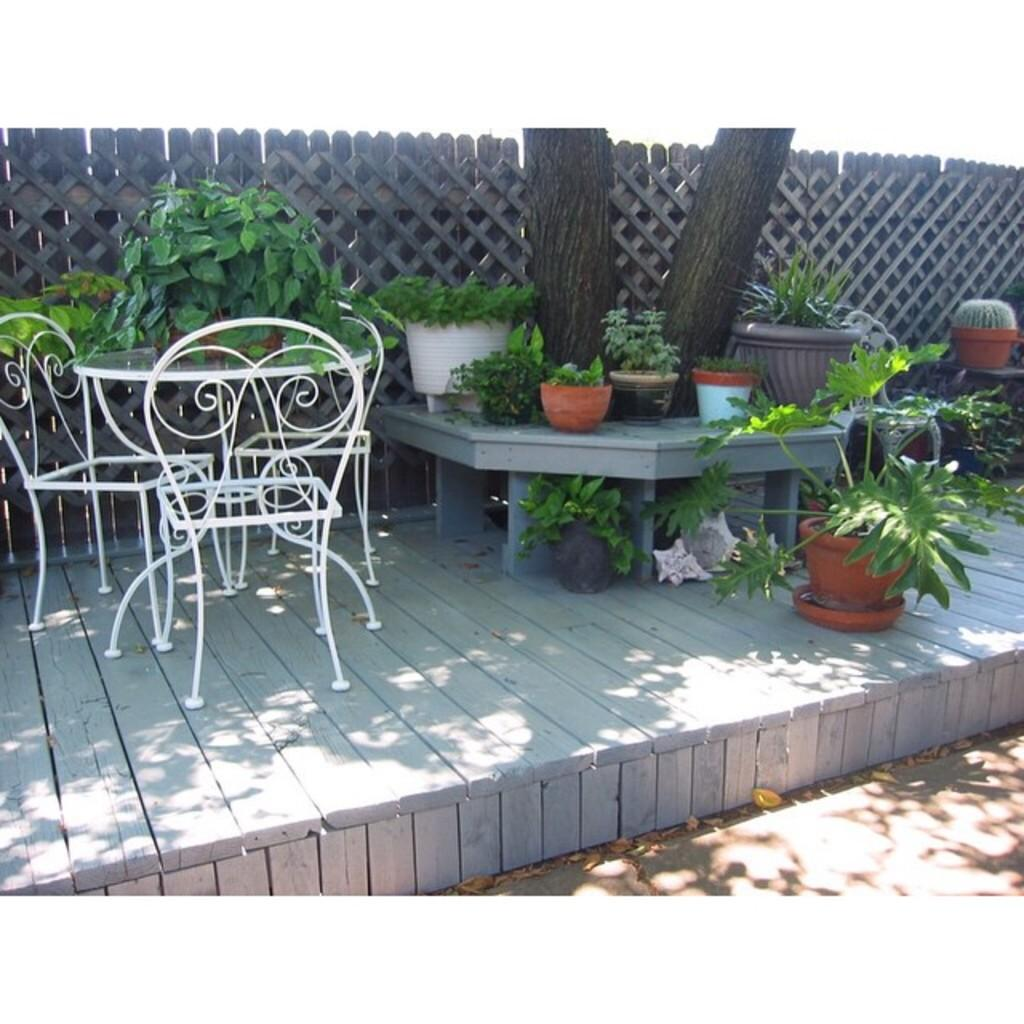What piece of furniture is present in the image? There is a table in the image. What can be found beside the table? Chairs are arranged beside the table. What type of plants are in the image? There are potted plants in the image. What large natural element is visible in the image? There is a big tree visible in the image. What type of structure is present in the image? There is a wall in the image. How are the elements arranged in the image? The elements are arranged in a place, indicating that they are organized and not randomly scattered. What type of yam is growing on the wall in the image? There is no yam growing on the wall in the image. Yams are not plants that grow on walls, and there is no mention of any yams in the provided facts. 